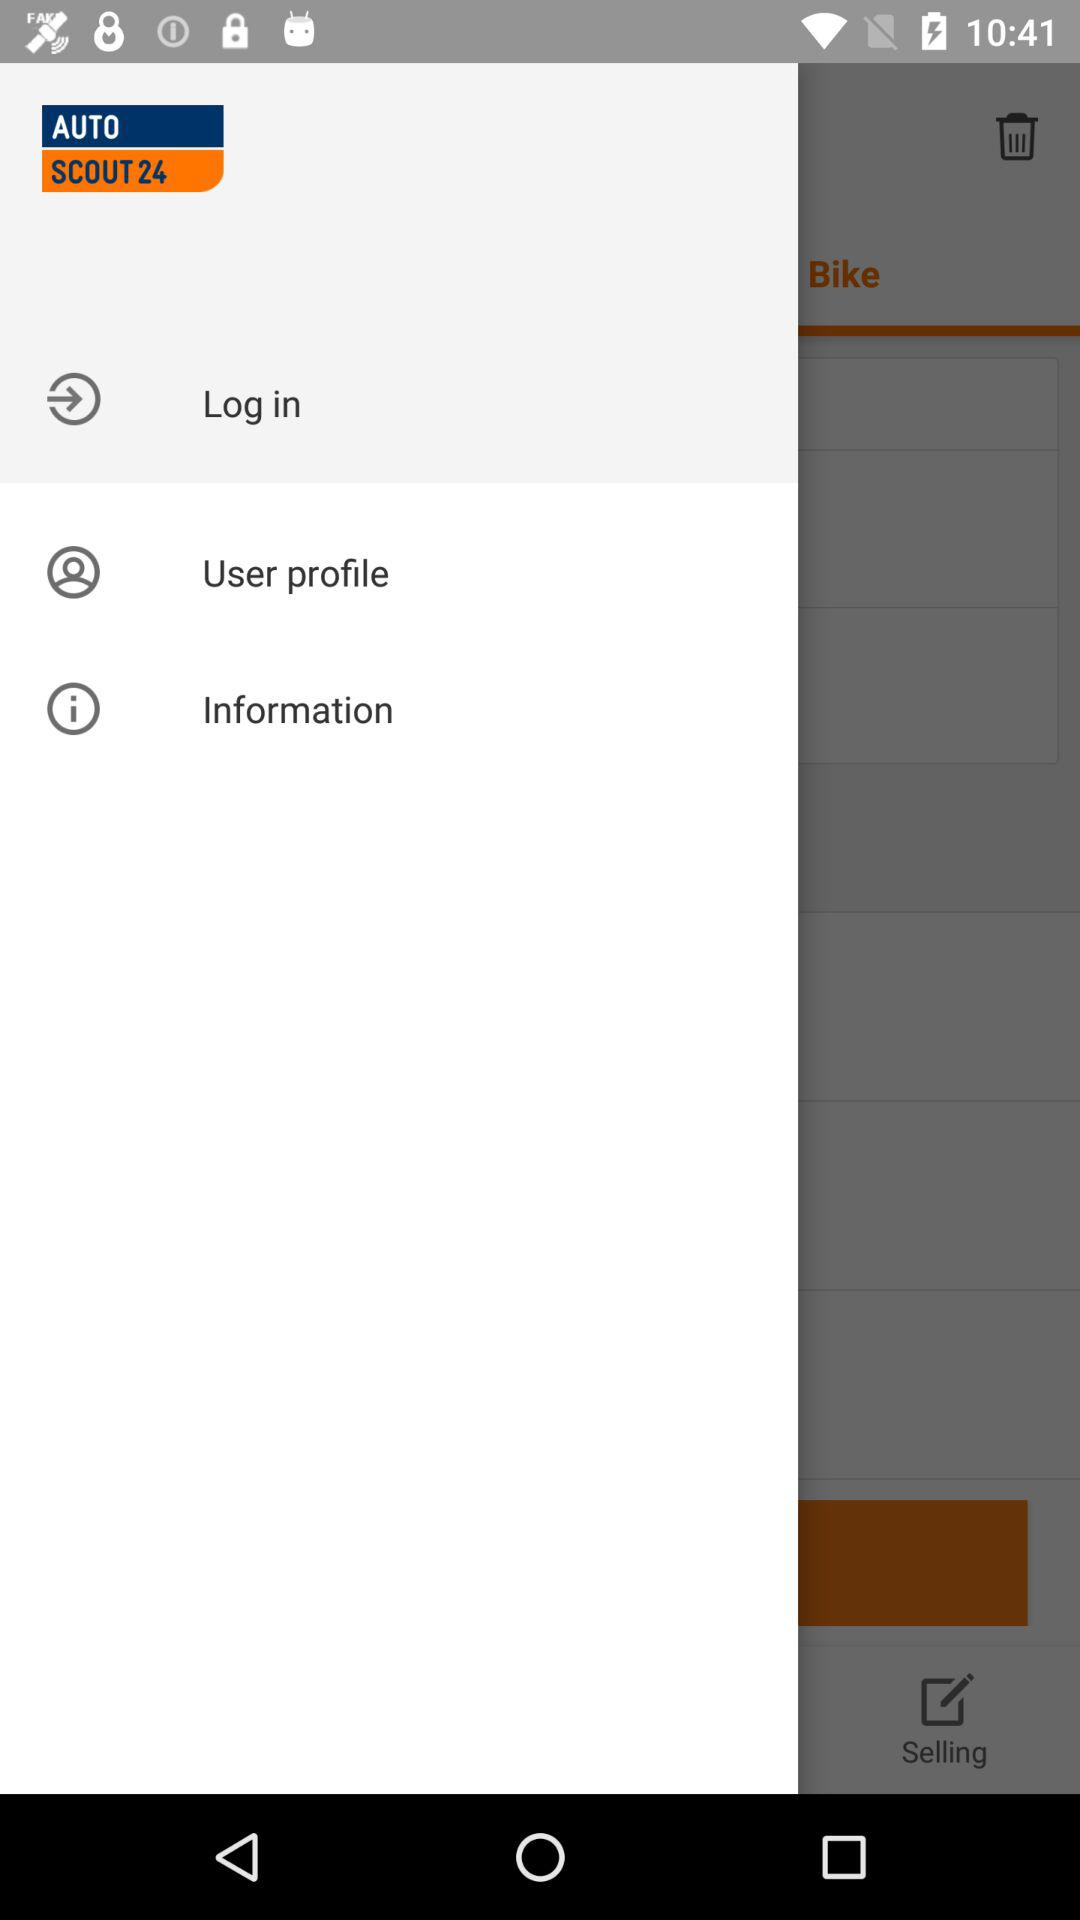What is the application name? The application name is "AUTO SCOUT 24". 